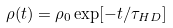Convert formula to latex. <formula><loc_0><loc_0><loc_500><loc_500>\rho ( t ) = \rho _ { 0 } \exp [ - t / \tau _ { H D } ]</formula> 